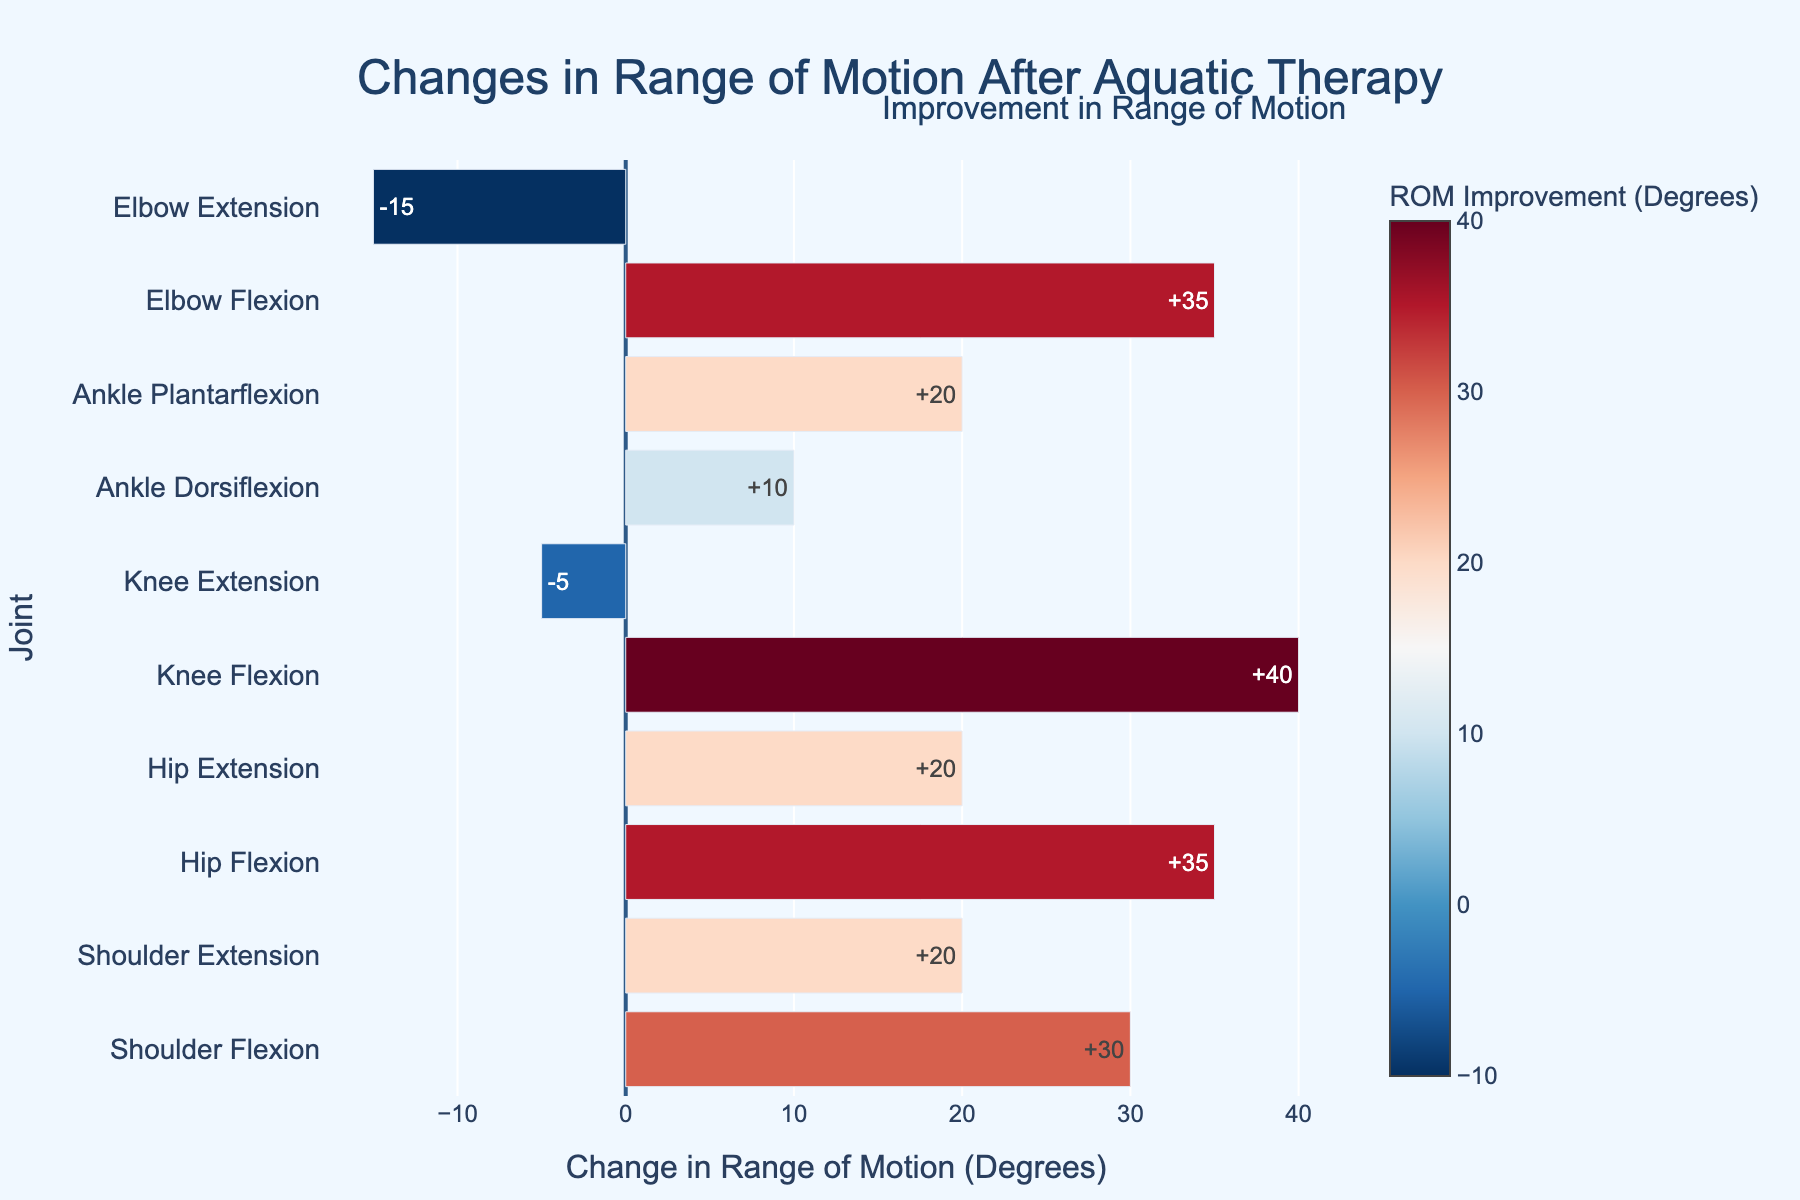Which joint showed the highest improvement in range of motion? To determine the joint with the highest improvement, look for the bar that extends the furthest to the right on the plot.
Answer: Knee Flexion Which joint had the smallest improvement in range of motion after aquatic therapy? Identify the bar with the shortest length to the right.
Answer: Knee Extension Which joints showed an improvement in extension after therapy? Look for bars corresponding to joints with "Extension" in their name that extend to the right.
Answer: Shoulder Extension, Hip Extension, Elbow Extension How much did the range of motion for shoulder flexion improve after therapy? Find the bar corresponding to Shoulder Flexion and read the numerical value.
Answer: 30 degrees Did any joint's range of motion remain unchanged or reduce after therapy? Look for any bar extending to the left (negative values) or very close to zero.
Answer: Knee Extension Between ankle dorsiflexion and ankle plantarflexion, which had a greater improvement? Compare the lengths of the bars corresponding to ankle dorsiflexion and ankle plantarflexion.
Answer: Ankle Plantarflexion By how many degrees did hip flexion improve post-therapy? Check the improvement value written next to the bar for Hip Flexion.
Answer: 35 degrees Is the improvement in elbow extension larger than in elbow flexion? Compare the length of the bars for Elbow Extension and Elbow Flexion.
Answer: No, Elbow Flexion improved more What is the average improvement in range of motion across all joints? Calculate the mean of all improvement values shown on the bars. (30+20+35+20+40-5+10+20+35-15)/10 = 19
Answer: 19 degrees How does the improvement in knee flexion compare to the improvement in hip extension? Directly compare the lengths of the bars for Knee Flexion and Hip Extension.
Answer: Knee Flexion improved more 